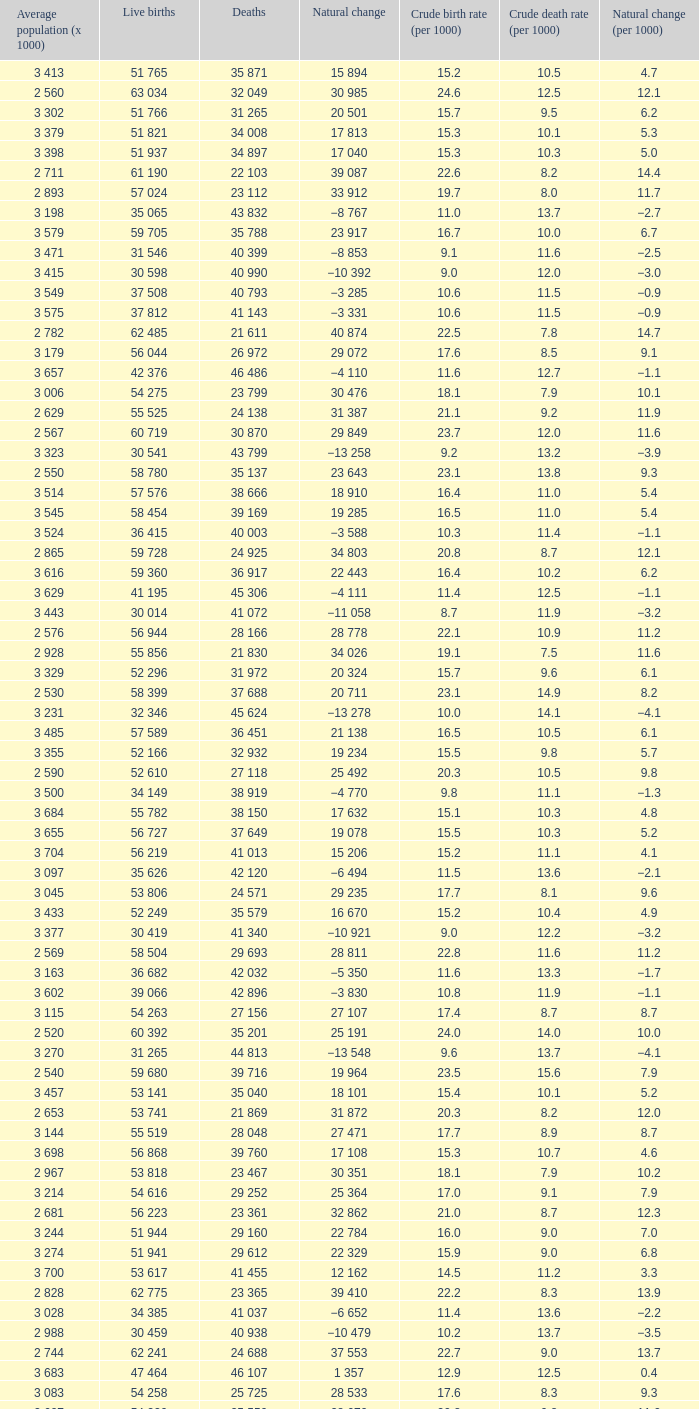Which Average population (x 1000) has a Crude death rate (per 1000) smaller than 10.9, and a Crude birth rate (per 1000) smaller than 19.7, and a Natural change (per 1000) of 8.7, and Live births of 54 263? 3 115. 